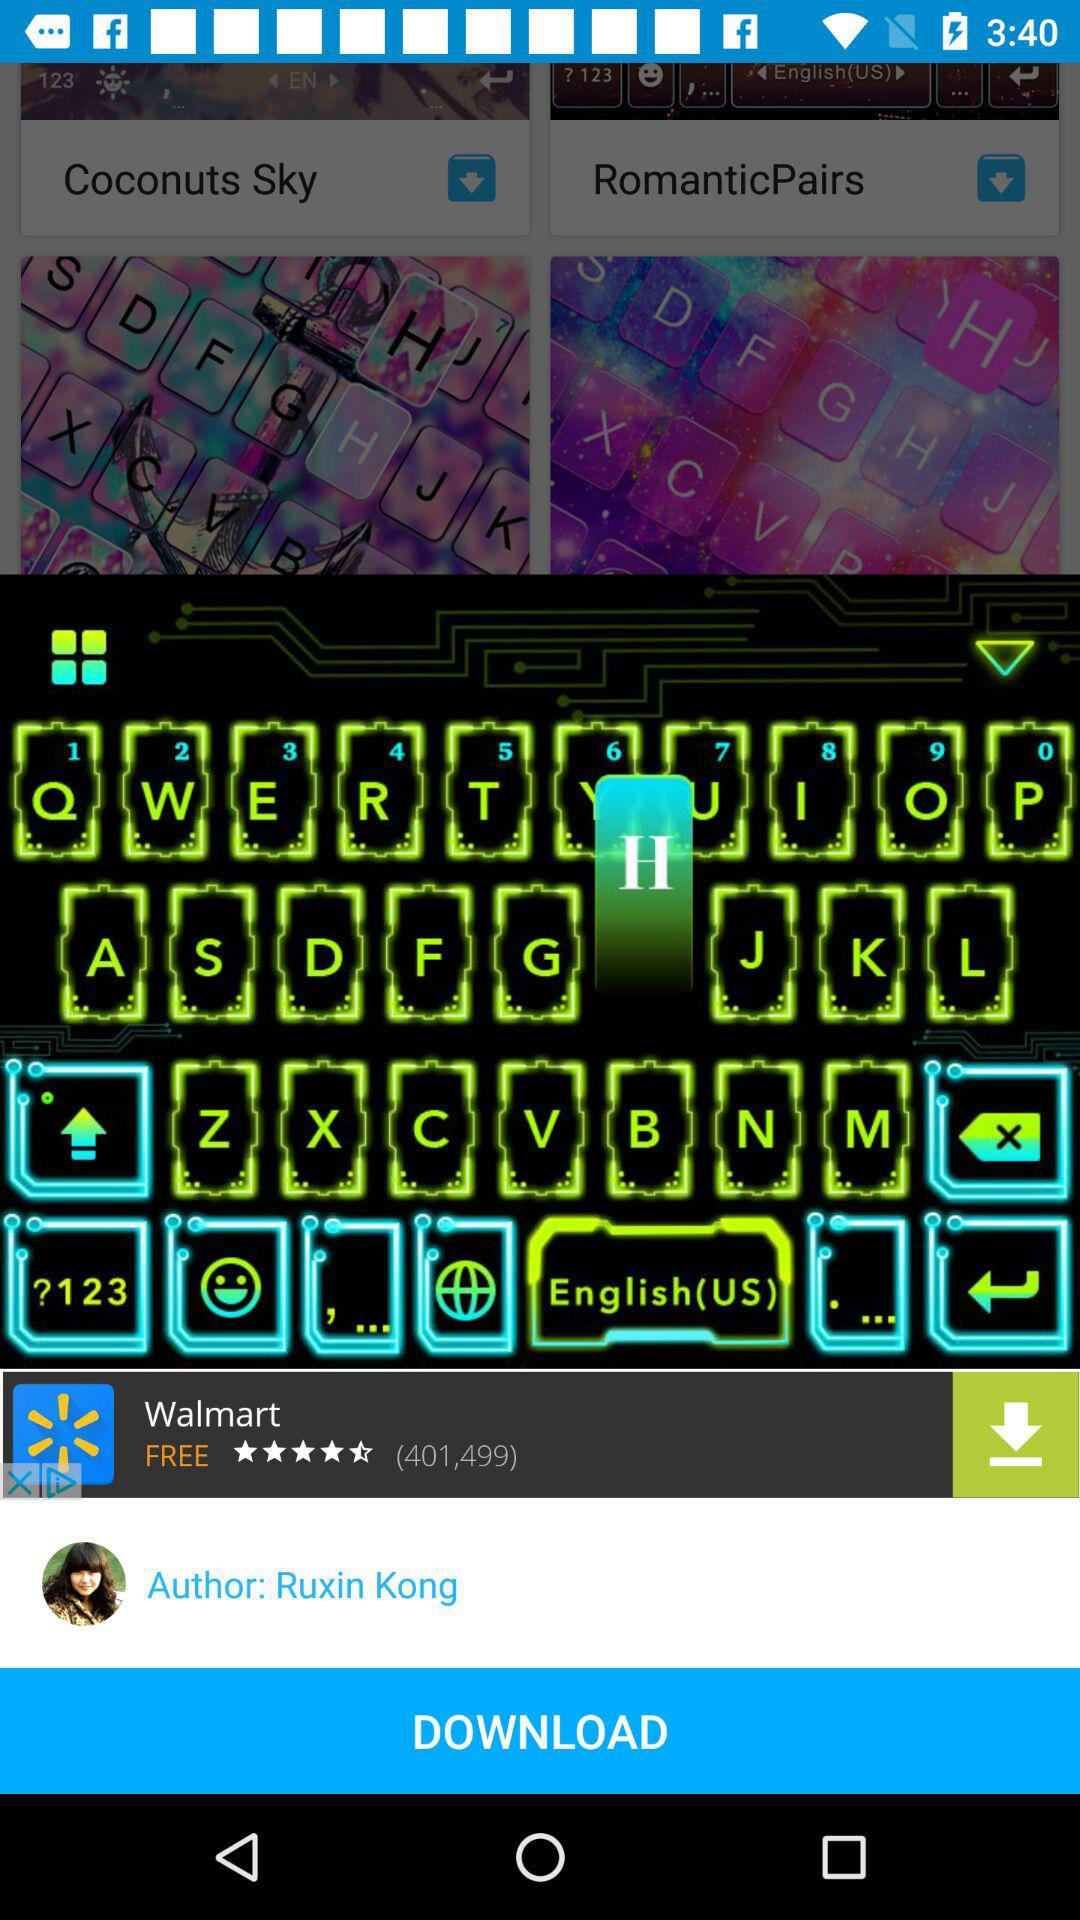What is the author name? The author's name is Ruxin Kong. 